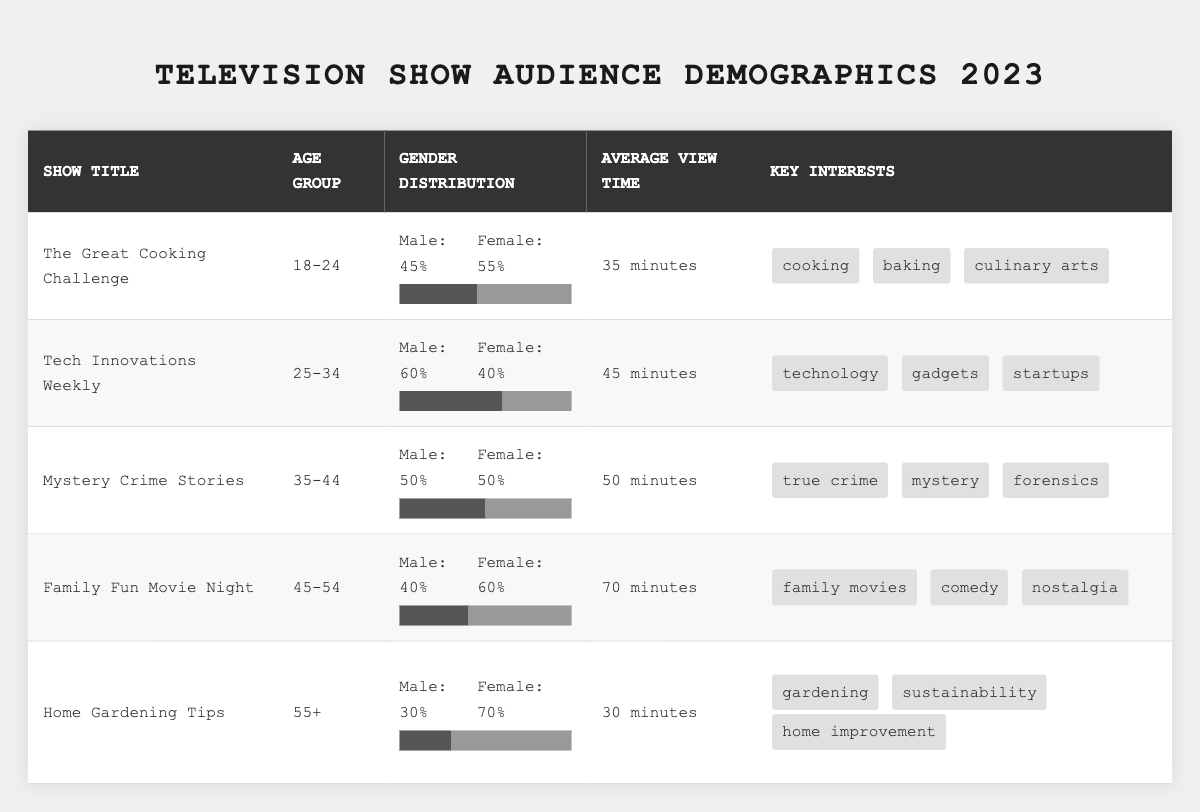What is the average view time for "The Great Cooking Challenge"? The table shows that the average view time for "The Great Cooking Challenge" is 35 minutes, as listed in its row.
Answer: 35 minutes Which show has the highest percentage of female viewers in the 45-54 age group? Looking at the table, "Family Fun Movie Night" has 60% female viewers in the 45-54 age group, which is higher than other shows in that category.
Answer: Family Fun Movie Night What is the male to female ratio for the show "Tech Innovations Weekly"? The gender distribution for "Tech Innovations Weekly" is 60% male and 40% female. The ratio can be calculated as 60:40, which simplifies to 3:2.
Answer: 3:2 Is the average view time for "Home Gardening Tips" more than 30 minutes? The table indicates that the average view time for "Home Gardening Tips" is exactly 30 minutes, so it is not more than 30 minutes.
Answer: No What is the total percentage of male viewers across all shows? To find the total percentage of male viewers, we add the male percentages of each show: 45 + 60 + 50 + 40 + 30 = 225%. Since there are 5 shows, the average male percentage is 225/5 = 45%.
Answer: 45% Which show has the lowest average view time? By comparing the average view times listed, "Home Gardening Tips" has the lowest average view time at 30 minutes.
Answer: Home Gardening Tips For the show "Mystery Crime Stories," what are the key interests? The key interests listed for "Mystery Crime Stories" in the table are true crime, mystery, and forensics, as noted in its row.
Answer: True crime, mystery, forensics How many shows have a balanced gender distribution (50% male and 50% female)? From the table, "Mystery Crime Stories" is the only show with a 50% gender distribution for both male and female viewers.
Answer: 1 What age group has the highest average view time? The average view times are 35, 45, 50, 70, and 30 minutes respectively for the age groups listed. The highest average view time is 70 minutes for the 45-54 age group, from "Family Fun Movie Night."
Answer: 45-54 If the view time for "Tech Innovations Weekly" increased by 10 minutes, what would be its new average view time? The current average view time for "Tech Innovations Weekly" is 45 minutes. If it increases by 10 minutes, the new average would be 45 + 10 = 55 minutes.
Answer: 55 minutes 